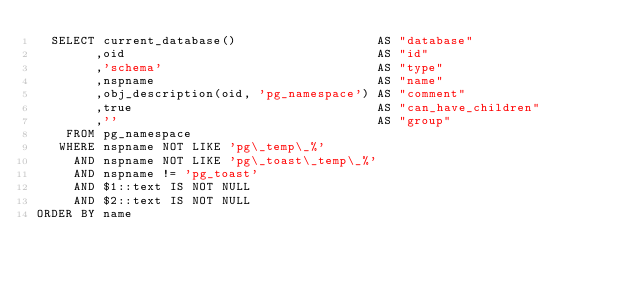Convert code to text. <code><loc_0><loc_0><loc_500><loc_500><_SQL_>  SELECT current_database()                   AS "database"
        ,oid                                  AS "id"
        ,'schema'                             AS "type"
        ,nspname                              AS "name"
        ,obj_description(oid, 'pg_namespace') AS "comment"
        ,true                                 AS "can_have_children"
        ,''                                   AS "group"
    FROM pg_namespace
   WHERE nspname NOT LIKE 'pg\_temp\_%'
     AND nspname NOT LIKE 'pg\_toast\_temp\_%'
     AND nspname != 'pg_toast'
     AND $1::text IS NOT NULL
     AND $2::text IS NOT NULL
ORDER BY name
</code> 